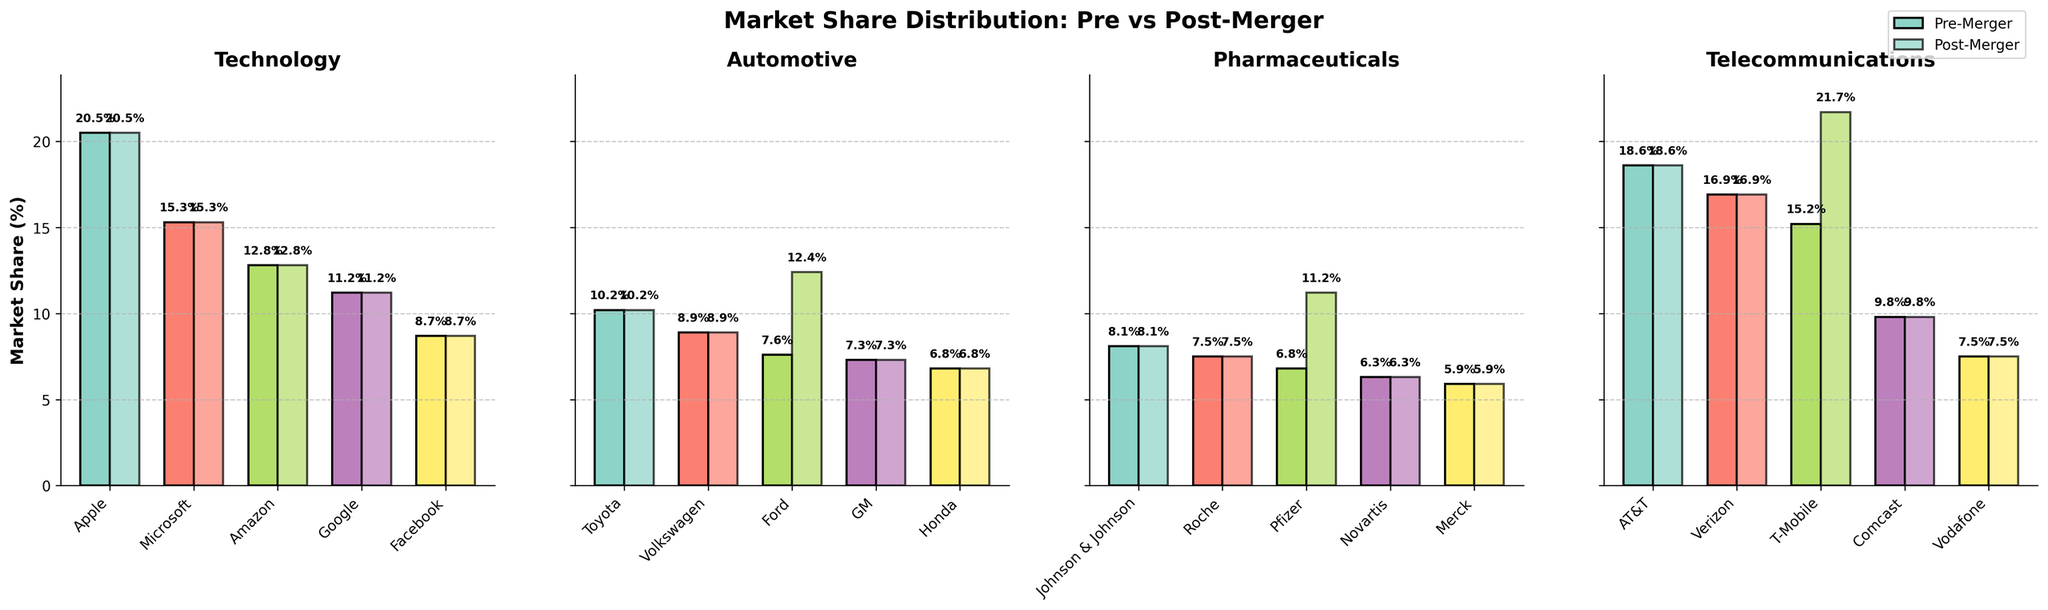What's the company with the highest market share increase in the Telecommunications industry post-merger? In the Telecommunications subplot, identify each company's pre-merger and post-merger values and calculate the difference. T-Mobile shows the largest increase from 15.2% to 21.7%, a 6.5% increase.
Answer: T-Mobile Which company in the Automotive industry had the largest increase in market share post-merger, and by how much? Analyze the pre- and post-merger market shares for each automotive company. Ford had the largest increase, from 7.6% to 12.4%, which is a 4.8% increase.
Answer: Ford, 4.8% In the Pharmaceuticals industry, what was the combined post-merger market share of Pfizer and Johnson & Johnson? Look at the post-merger shares in the Pharmaceuticals subplot. Add Pfizer's (11.2%) and Johnson & Johnson's (8.1%) post-merger market shares: 11.2% + 8.1% = 19.3%.
Answer: 19.3% Which industry showed no change in market share distribution post-merger? Compare the pre- and post-merger market shares for each industry and look for no differences. The Technology industry shows no change across all companies.
Answer: Technology Between GM and Ford in the Automotive industry, which company had a higher market share post-merger and what is the difference? Identify the post-merger shares of GM (7.3%) and Ford (12.4%). Subtract GM's share from Ford's share: 12.4% - 7.3% = 5.1%.
Answer: Ford, 5.1% How do the pre- and post-merger shares of the top two companies in the Telecommunications industry compare? Identify the top two companies in terms of pre-merger shares, which are AT&T (18.6%) and Verizon (16.9%). Post-merger, they remain the same with no changes: AT&T (18.6%) and Verizon (16.9%).
Answer: AT&T and Verizon, no change By how much did the total market share change for Amazon and Google in the Technology industry from pre- to post-merger? The Technology industry shows no change in individual companies' shares. Therefore, Amazon (12.8%) and Google (11.2%) have no changes. Their total both pre- and post-merger is 12.8% + 11.2% = 24%. Change = 0%.
Answer: 0% In the Pharmaceuticals industry, which company had the highest post-merger market share gain? Compare the differences in pre- and post-merger shares in the Pharmaceuticals subplot. Pfizer had the highest gain, from 6.8% to 11.2%, an increase of 4.4%.
Answer: Pfizer Comparing post-merger shares, which industry had the most companies with unchanged market shares? Count the number of companies in each industry that had unchanged market shares. Technology had all its companies with unchanged shares (5 companies), while the others had at least one company with a change.
Answer: Technology 